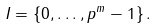<formula> <loc_0><loc_0><loc_500><loc_500>I = \{ 0 , \dots , p ^ { m } - 1 \} \, .</formula> 